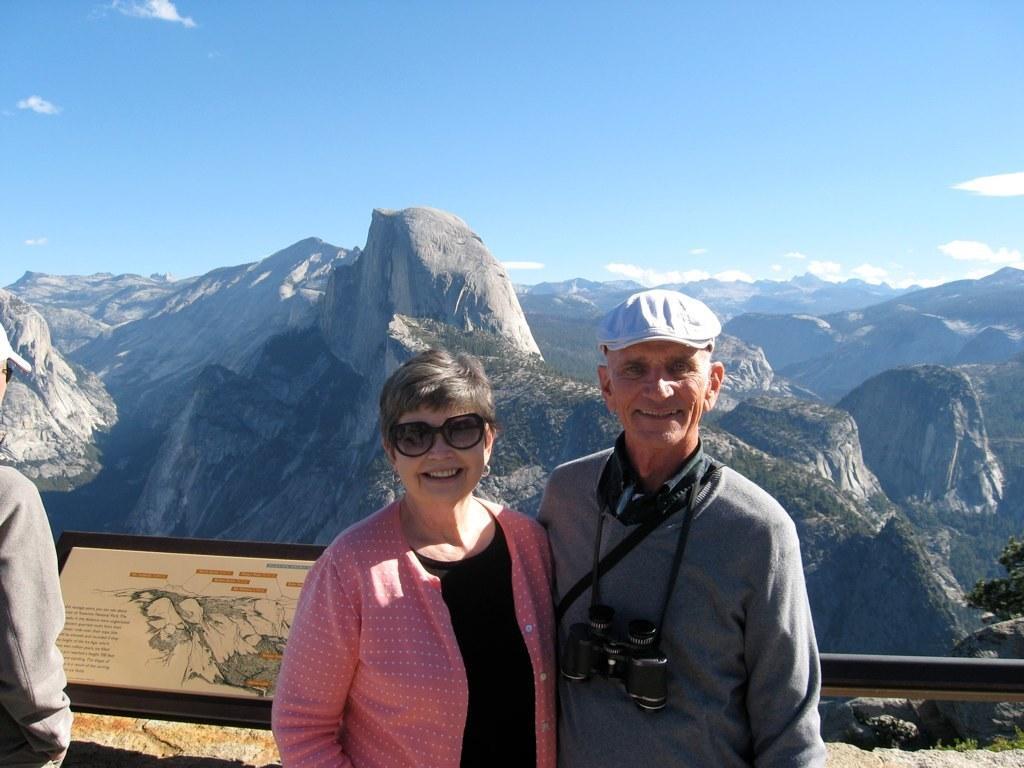How would you summarize this image in a sentence or two? This picture few people standing. We see a woman wore sunglasses on her face and a man wore a cap on is head and a binocular and we see a board with some text and we see hills and trees and a blue cloudy Sky 